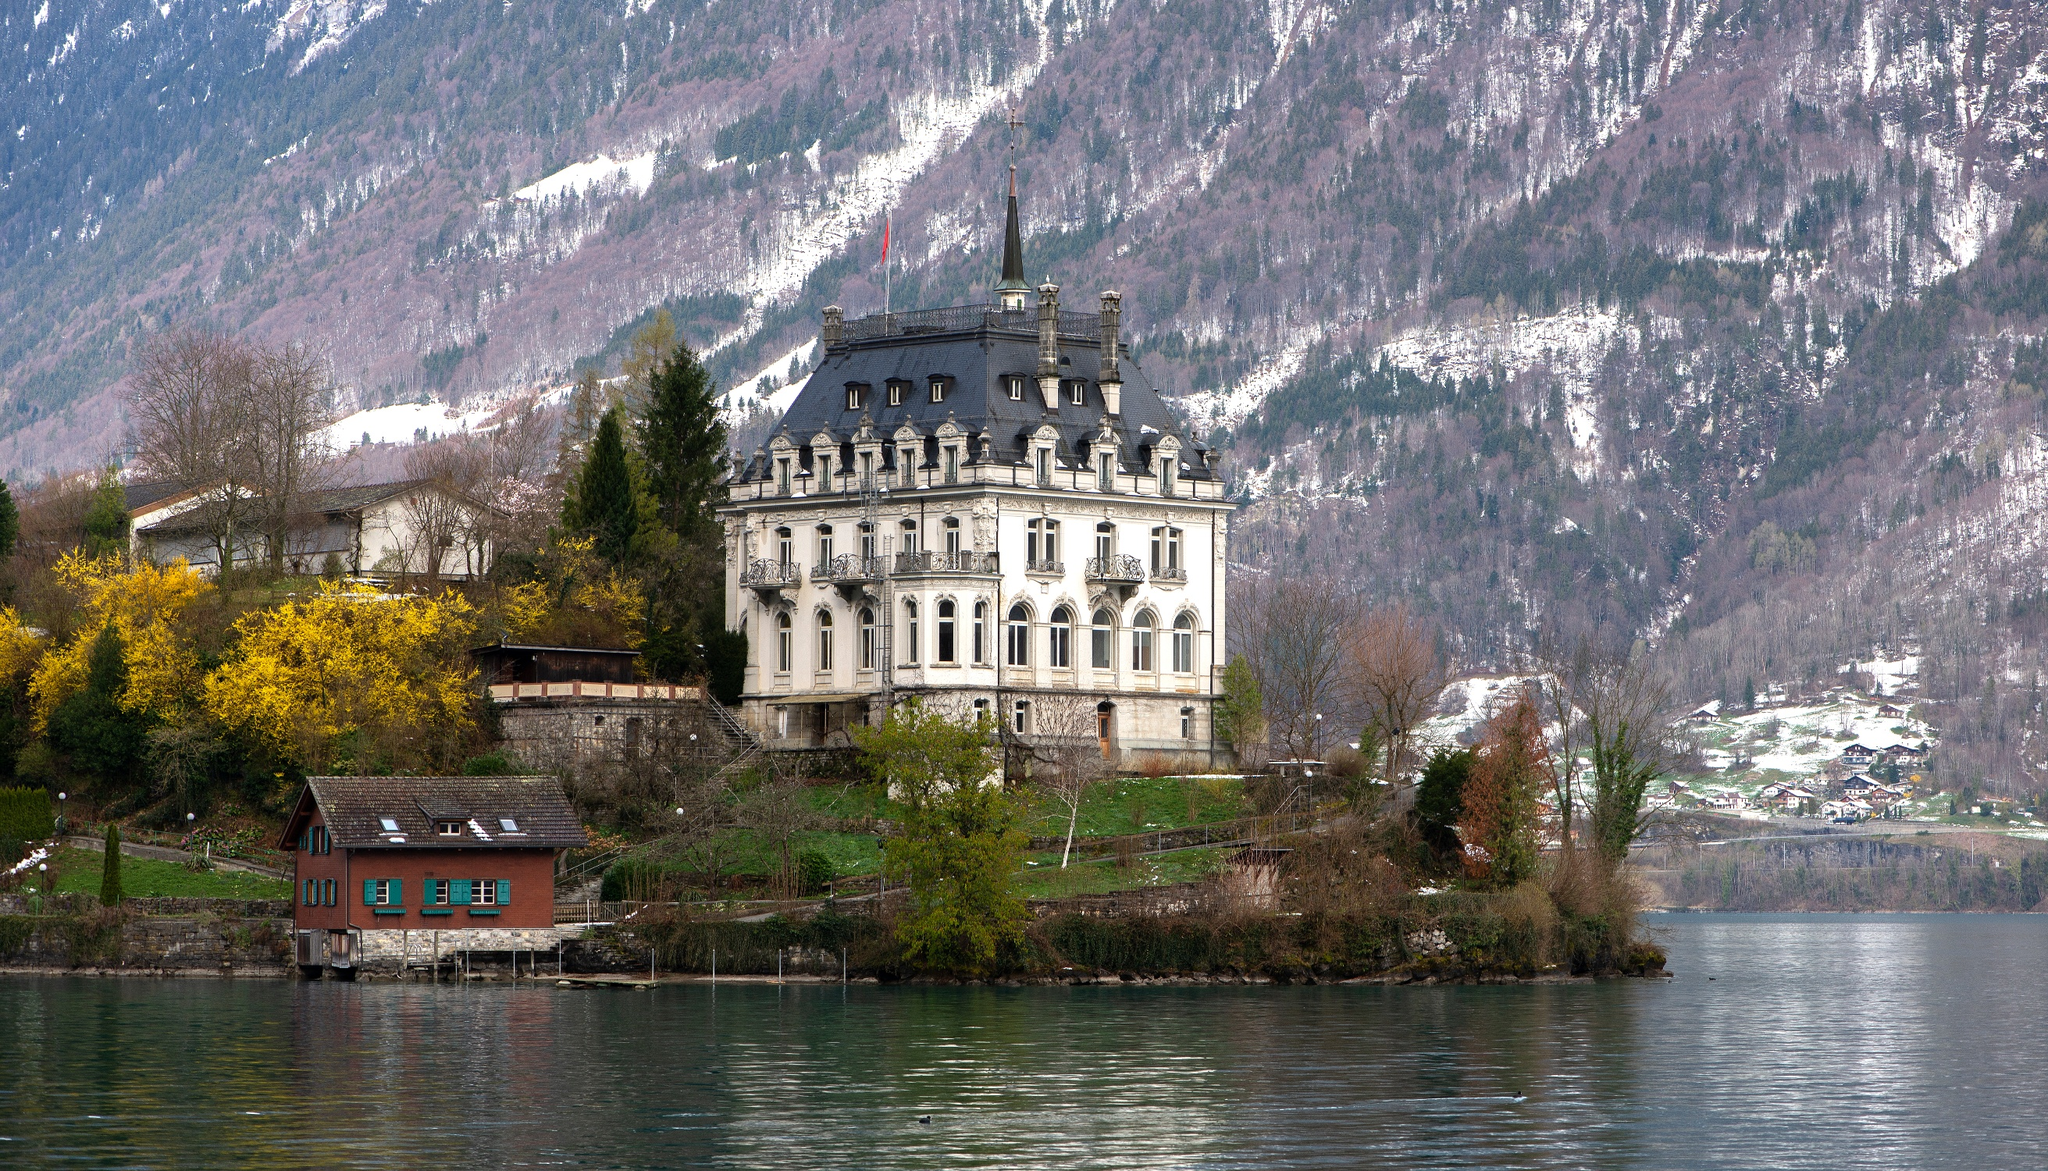What do you think is going on in this snapshot? The image showcases the magnificent Iseltwald Castle, a Swiss heritage landmark, gracefully perched on the edge of Lake Brienz. This three-story architectural marvel, boasting a steep roof and a distinctive tower, stands out with its pristine white facade interlaced with black trim. Surrounding the castle is a lively array of trees and shrubs that further heighten its allure, complemented by a neighboring wooden house to the left. The panorama is enriched by the awe-inspiring mountain range in the background, its peaks adorned with snow, enhancing the serene beauty of the tranquil lake in the foreground. This picture exquisitely captures the grandeur of the castle and the sublime Swiss landscape, offering a glimpse into the tranquility and historical significance of the region. 